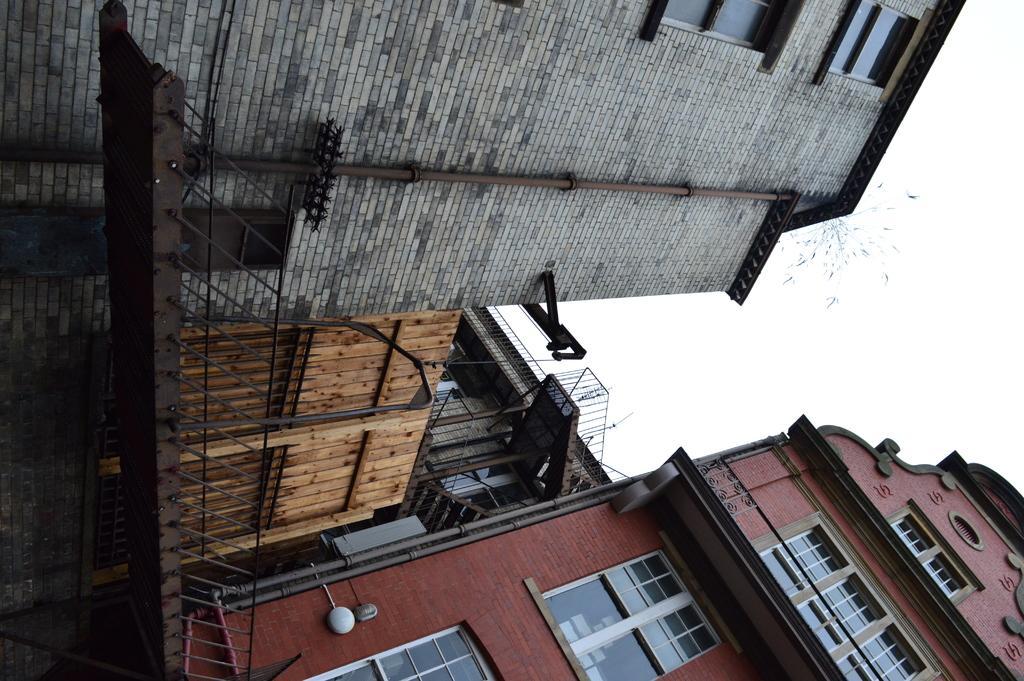How would you summarize this image in a sentence or two? In the image there are buildings with walls, windows, roofs and pipes. In front of the buildings there is a bridge with railing. Behind the bridge there is a wooden gate. Behind the gate there is a building with walls, steps, railings and windows. In the background there is sky. 